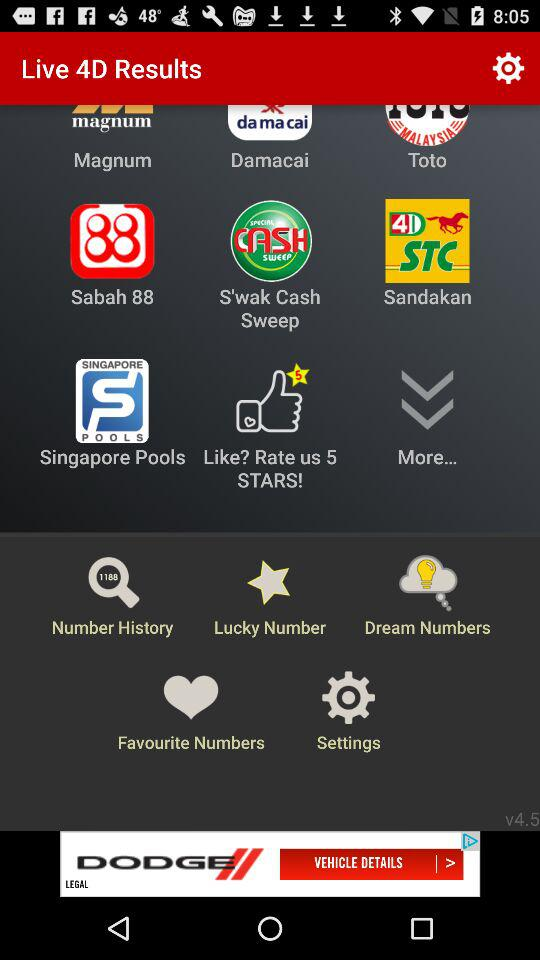What is Free Result Notification?
When the provided information is insufficient, respond with <no answer>. <no answer> 